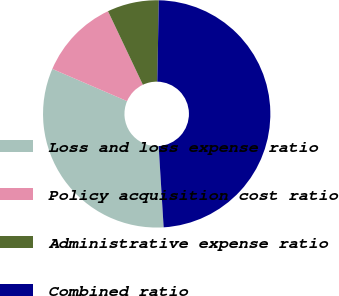Convert chart to OTSL. <chart><loc_0><loc_0><loc_500><loc_500><pie_chart><fcel>Loss and loss expense ratio<fcel>Policy acquisition cost ratio<fcel>Administrative expense ratio<fcel>Combined ratio<nl><fcel>32.45%<fcel>11.48%<fcel>7.34%<fcel>48.73%<nl></chart> 